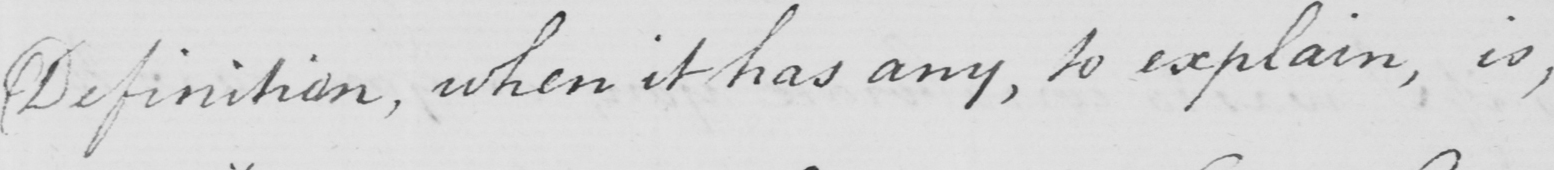What does this handwritten line say? Definition , when it has any , to explain , is , 